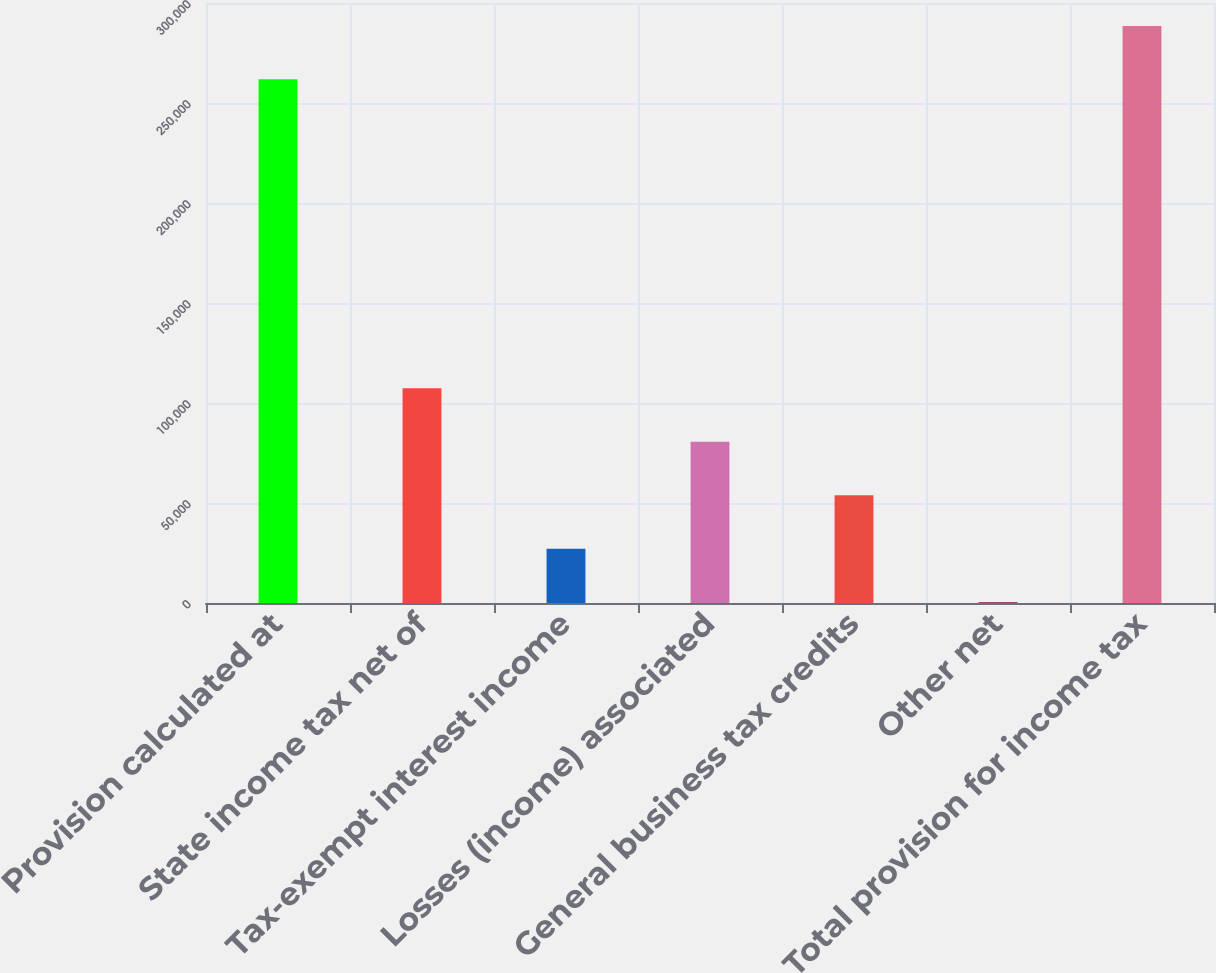<chart> <loc_0><loc_0><loc_500><loc_500><bar_chart><fcel>Provision calculated at<fcel>State income tax net of<fcel>Tax-exempt interest income<fcel>Losses (income) associated<fcel>General business tax credits<fcel>Other net<fcel>Total provision for income tax<nl><fcel>261816<fcel>107373<fcel>27161.3<fcel>80635.9<fcel>53898.6<fcel>424<fcel>288553<nl></chart> 